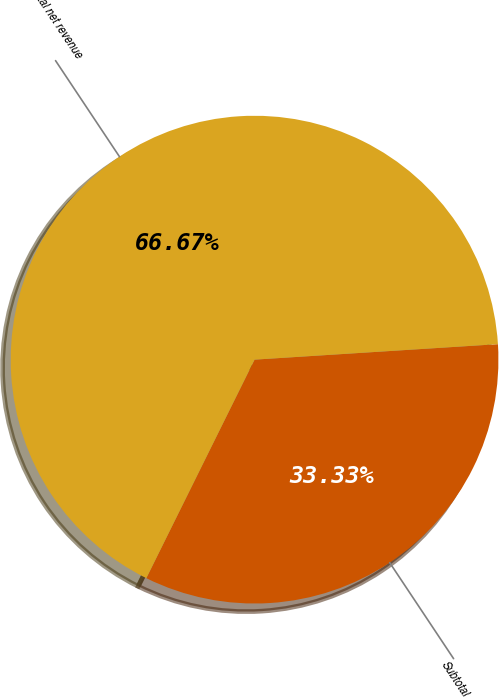Convert chart. <chart><loc_0><loc_0><loc_500><loc_500><pie_chart><fcel>Subtotal<fcel>Total net revenue<nl><fcel>33.33%<fcel>66.67%<nl></chart> 